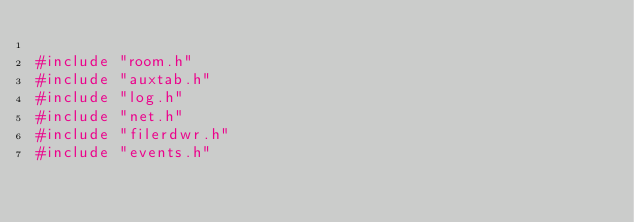<code> <loc_0><loc_0><loc_500><loc_500><_C++_>
#include "room.h"
#include "auxtab.h"
#include "log.h"
#include "net.h"
#include "filerdwr.h"
#include "events.h"</code> 